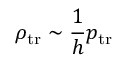Convert formula to latex. <formula><loc_0><loc_0><loc_500><loc_500>\rho _ { t r } \sim \frac { 1 } { h } p _ { t r }</formula> 